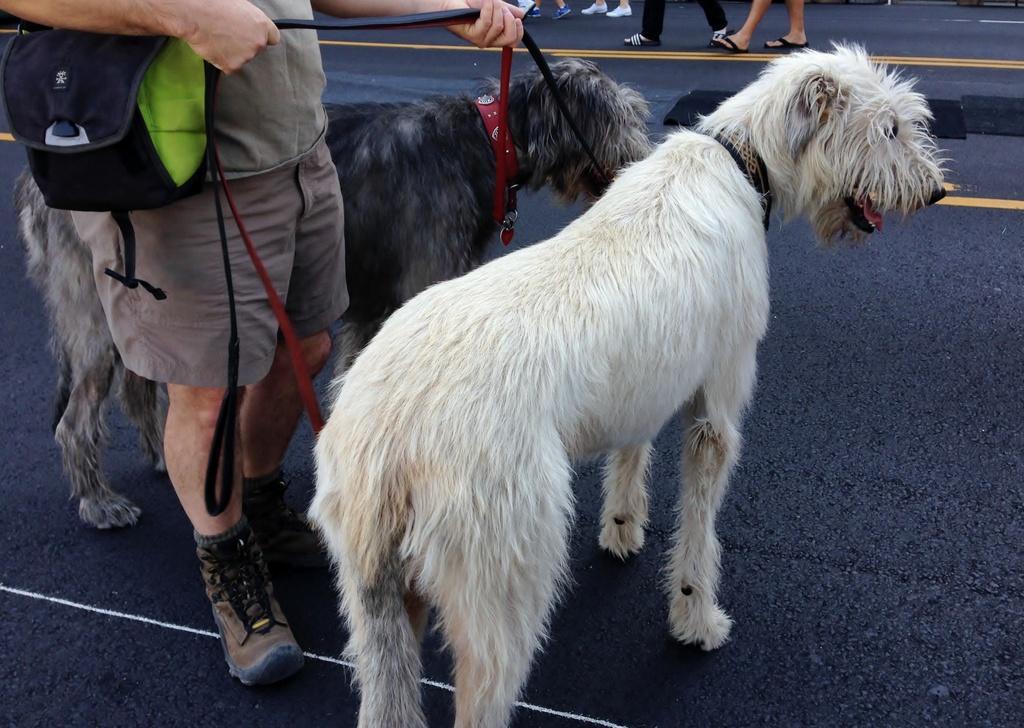Could you give a brief overview of what you see in this image? A person is holding belts which are tied to dogs. Top of the image we can see people legs. To this person there is a bag. 